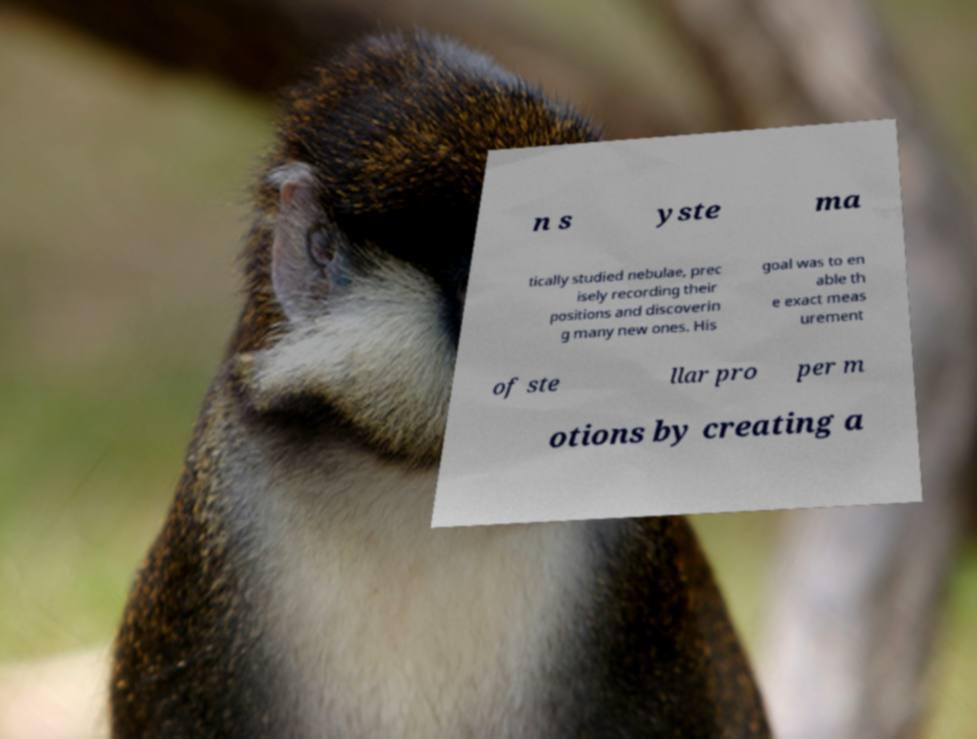Could you assist in decoding the text presented in this image and type it out clearly? n s yste ma tically studied nebulae, prec isely recording their positions and discoverin g many new ones. His goal was to en able th e exact meas urement of ste llar pro per m otions by creating a 